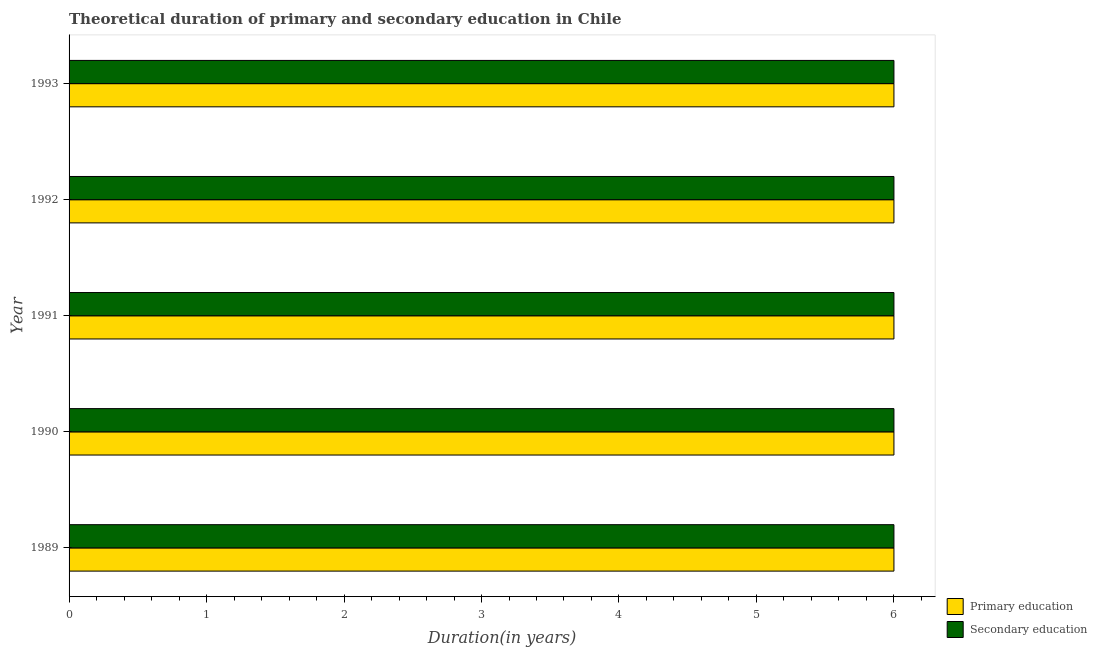Are the number of bars on each tick of the Y-axis equal?
Offer a very short reply. Yes. In how many cases, is the number of bars for a given year not equal to the number of legend labels?
Offer a very short reply. 0. What is the duration of primary education in 1993?
Provide a succinct answer. 6. Across all years, what is the minimum duration of primary education?
Your answer should be very brief. 6. In which year was the duration of primary education maximum?
Provide a short and direct response. 1989. In which year was the duration of primary education minimum?
Ensure brevity in your answer.  1989. What is the total duration of primary education in the graph?
Ensure brevity in your answer.  30. What is the difference between the duration of primary education in 1991 and that in 1993?
Keep it short and to the point. 0. What is the difference between the duration of secondary education in 1989 and the duration of primary education in 1993?
Make the answer very short. 0. What is the ratio of the duration of secondary education in 1989 to that in 1992?
Give a very brief answer. 1. Is the duration of secondary education in 1989 less than that in 1991?
Ensure brevity in your answer.  No. What is the difference between the highest and the second highest duration of secondary education?
Offer a terse response. 0. Is the sum of the duration of primary education in 1992 and 1993 greater than the maximum duration of secondary education across all years?
Keep it short and to the point. Yes. What does the 2nd bar from the bottom in 1989 represents?
Your answer should be very brief. Secondary education. How many bars are there?
Provide a short and direct response. 10. How many years are there in the graph?
Provide a short and direct response. 5. What is the difference between two consecutive major ticks on the X-axis?
Make the answer very short. 1. Does the graph contain grids?
Your answer should be compact. No. How many legend labels are there?
Give a very brief answer. 2. How are the legend labels stacked?
Keep it short and to the point. Vertical. What is the title of the graph?
Offer a very short reply. Theoretical duration of primary and secondary education in Chile. Does "Taxes on profits and capital gains" appear as one of the legend labels in the graph?
Give a very brief answer. No. What is the label or title of the X-axis?
Provide a succinct answer. Duration(in years). What is the label or title of the Y-axis?
Make the answer very short. Year. What is the Duration(in years) of Primary education in 1990?
Your answer should be compact. 6. What is the Duration(in years) in Secondary education in 1990?
Offer a terse response. 6. What is the Duration(in years) of Secondary education in 1991?
Offer a terse response. 6. What is the Duration(in years) of Secondary education in 1992?
Give a very brief answer. 6. What is the Duration(in years) in Secondary education in 1993?
Provide a succinct answer. 6. Across all years, what is the minimum Duration(in years) in Primary education?
Your response must be concise. 6. Across all years, what is the minimum Duration(in years) of Secondary education?
Offer a terse response. 6. What is the difference between the Duration(in years) in Primary education in 1989 and that in 1990?
Your answer should be compact. 0. What is the difference between the Duration(in years) of Secondary education in 1989 and that in 1990?
Your answer should be very brief. 0. What is the difference between the Duration(in years) of Primary education in 1989 and that in 1993?
Keep it short and to the point. 0. What is the difference between the Duration(in years) of Secondary education in 1989 and that in 1993?
Ensure brevity in your answer.  0. What is the difference between the Duration(in years) in Primary education in 1990 and that in 1991?
Keep it short and to the point. 0. What is the difference between the Duration(in years) in Primary education in 1990 and that in 1992?
Offer a very short reply. 0. What is the difference between the Duration(in years) in Primary education in 1990 and that in 1993?
Provide a succinct answer. 0. What is the difference between the Duration(in years) in Primary education in 1991 and that in 1992?
Your response must be concise. 0. What is the difference between the Duration(in years) of Secondary education in 1991 and that in 1992?
Provide a short and direct response. 0. What is the difference between the Duration(in years) in Secondary education in 1991 and that in 1993?
Your response must be concise. 0. What is the difference between the Duration(in years) of Primary education in 1992 and that in 1993?
Offer a very short reply. 0. What is the difference between the Duration(in years) of Secondary education in 1992 and that in 1993?
Your answer should be very brief. 0. What is the difference between the Duration(in years) in Primary education in 1989 and the Duration(in years) in Secondary education in 1993?
Make the answer very short. 0. What is the difference between the Duration(in years) of Primary education in 1990 and the Duration(in years) of Secondary education in 1991?
Offer a very short reply. 0. What is the difference between the Duration(in years) of Primary education in 1990 and the Duration(in years) of Secondary education in 1992?
Offer a very short reply. 0. What is the difference between the Duration(in years) in Primary education in 1990 and the Duration(in years) in Secondary education in 1993?
Provide a succinct answer. 0. What is the difference between the Duration(in years) of Primary education in 1992 and the Duration(in years) of Secondary education in 1993?
Ensure brevity in your answer.  0. What is the average Duration(in years) in Primary education per year?
Your answer should be compact. 6. What is the average Duration(in years) in Secondary education per year?
Provide a short and direct response. 6. In the year 1990, what is the difference between the Duration(in years) of Primary education and Duration(in years) of Secondary education?
Ensure brevity in your answer.  0. In the year 1991, what is the difference between the Duration(in years) of Primary education and Duration(in years) of Secondary education?
Offer a very short reply. 0. In the year 1993, what is the difference between the Duration(in years) of Primary education and Duration(in years) of Secondary education?
Offer a very short reply. 0. What is the ratio of the Duration(in years) in Primary education in 1989 to that in 1990?
Provide a succinct answer. 1. What is the ratio of the Duration(in years) of Primary education in 1989 to that in 1991?
Provide a succinct answer. 1. What is the ratio of the Duration(in years) of Secondary education in 1989 to that in 1992?
Ensure brevity in your answer.  1. What is the ratio of the Duration(in years) of Secondary education in 1989 to that in 1993?
Give a very brief answer. 1. What is the ratio of the Duration(in years) of Secondary education in 1990 to that in 1992?
Provide a short and direct response. 1. What is the ratio of the Duration(in years) of Secondary education in 1990 to that in 1993?
Offer a very short reply. 1. What is the ratio of the Duration(in years) in Primary education in 1991 to that in 1992?
Make the answer very short. 1. What is the ratio of the Duration(in years) of Secondary education in 1991 to that in 1992?
Give a very brief answer. 1. What is the ratio of the Duration(in years) of Secondary education in 1992 to that in 1993?
Provide a short and direct response. 1. What is the difference between the highest and the second highest Duration(in years) of Secondary education?
Provide a short and direct response. 0. 